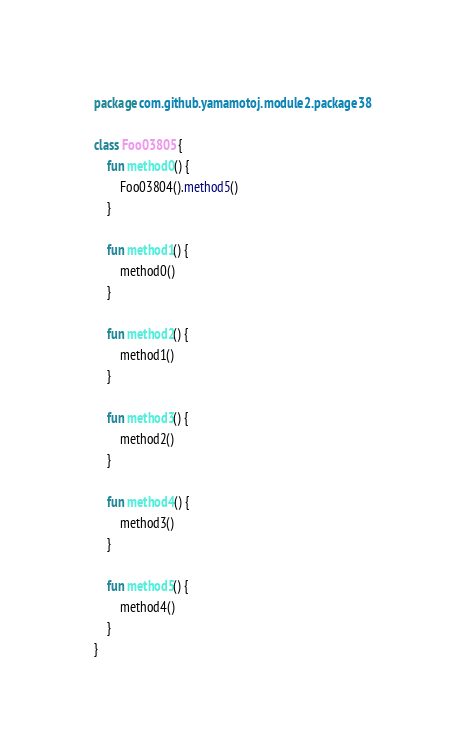<code> <loc_0><loc_0><loc_500><loc_500><_Kotlin_>package com.github.yamamotoj.module2.package38

class Foo03805 {
    fun method0() {
        Foo03804().method5()
    }

    fun method1() {
        method0()
    }

    fun method2() {
        method1()
    }

    fun method3() {
        method2()
    }

    fun method4() {
        method3()
    }

    fun method5() {
        method4()
    }
}
</code> 